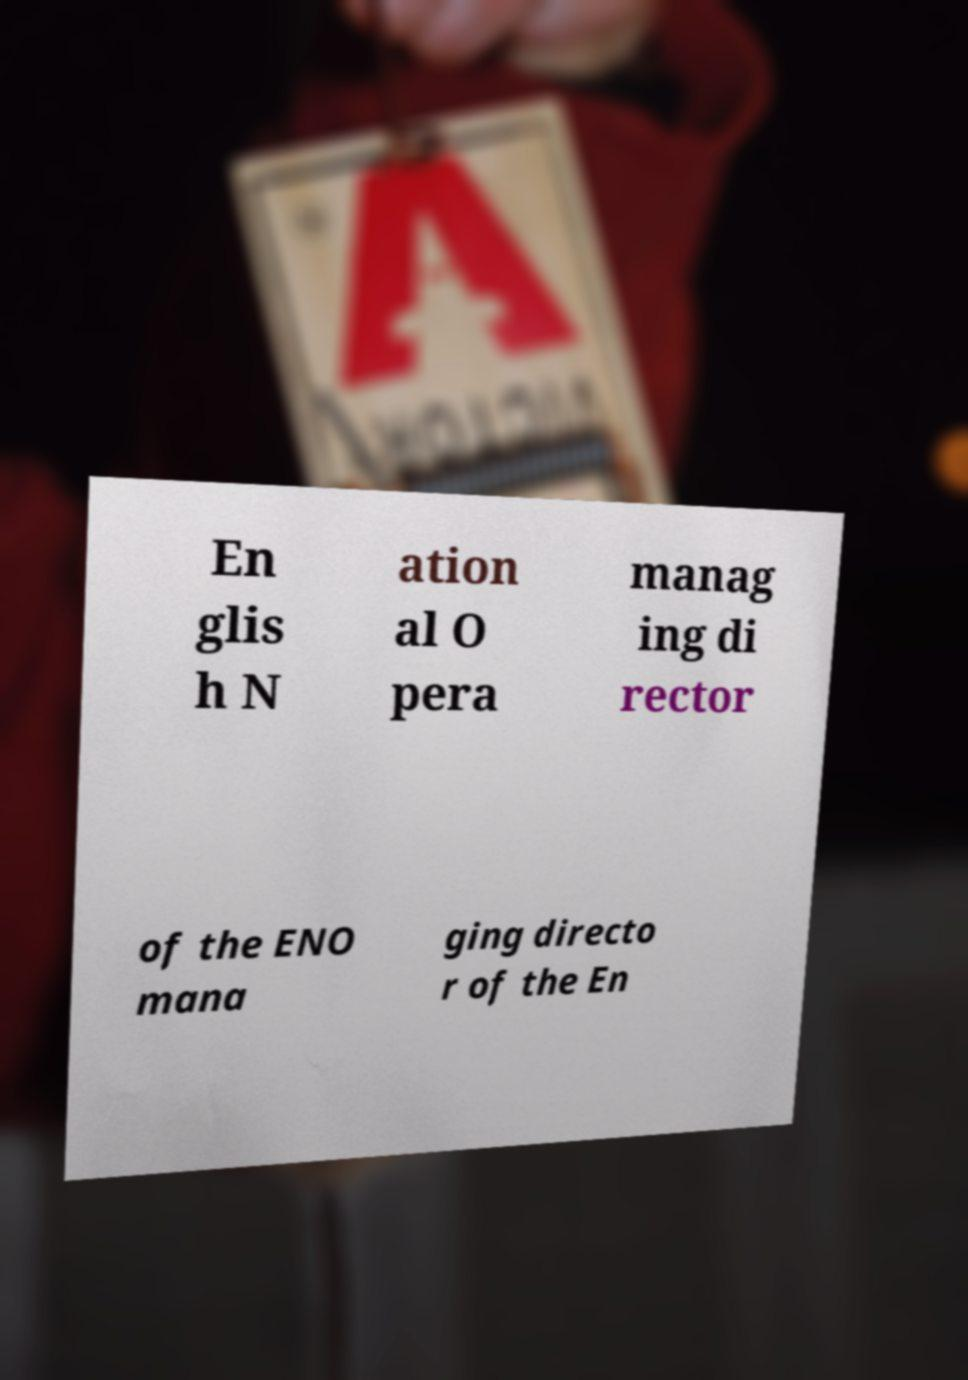Could you assist in decoding the text presented in this image and type it out clearly? En glis h N ation al O pera manag ing di rector of the ENO mana ging directo r of the En 